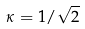<formula> <loc_0><loc_0><loc_500><loc_500>\kappa = 1 / \sqrt { 2 }</formula> 